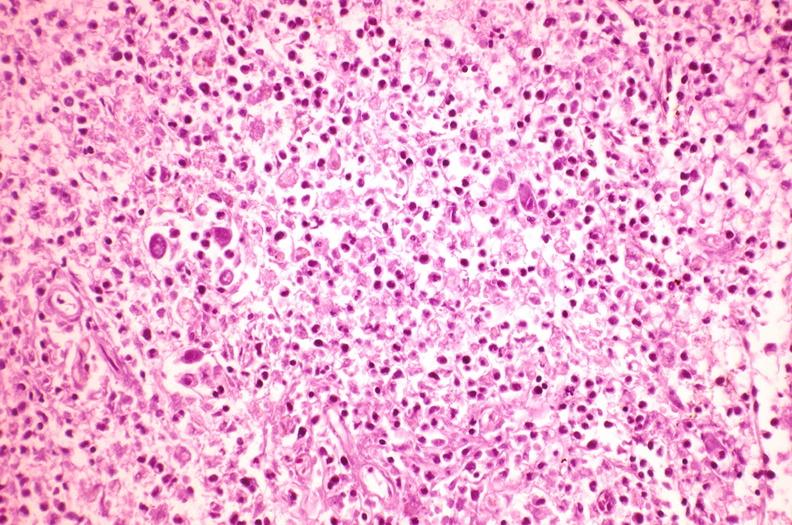s hematologic present?
Answer the question using a single word or phrase. Yes 